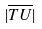Convert formula to latex. <formula><loc_0><loc_0><loc_500><loc_500>| \overline { T U } |</formula> 